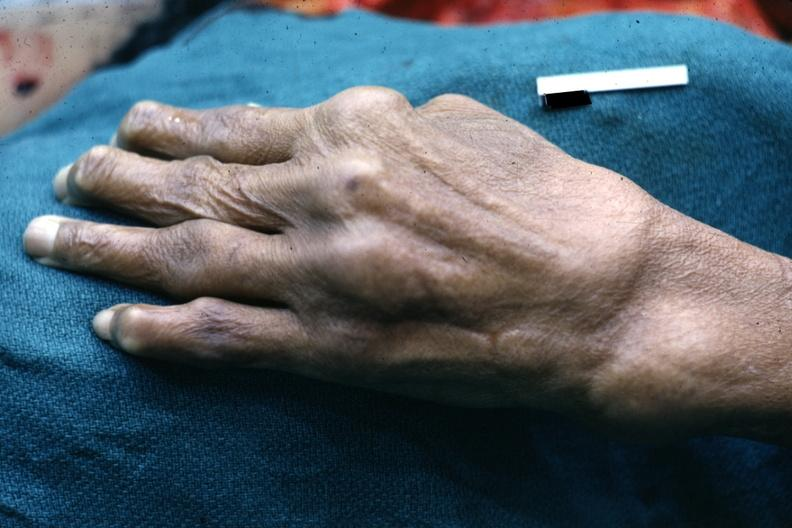s coronary artery present?
Answer the question using a single word or phrase. No 